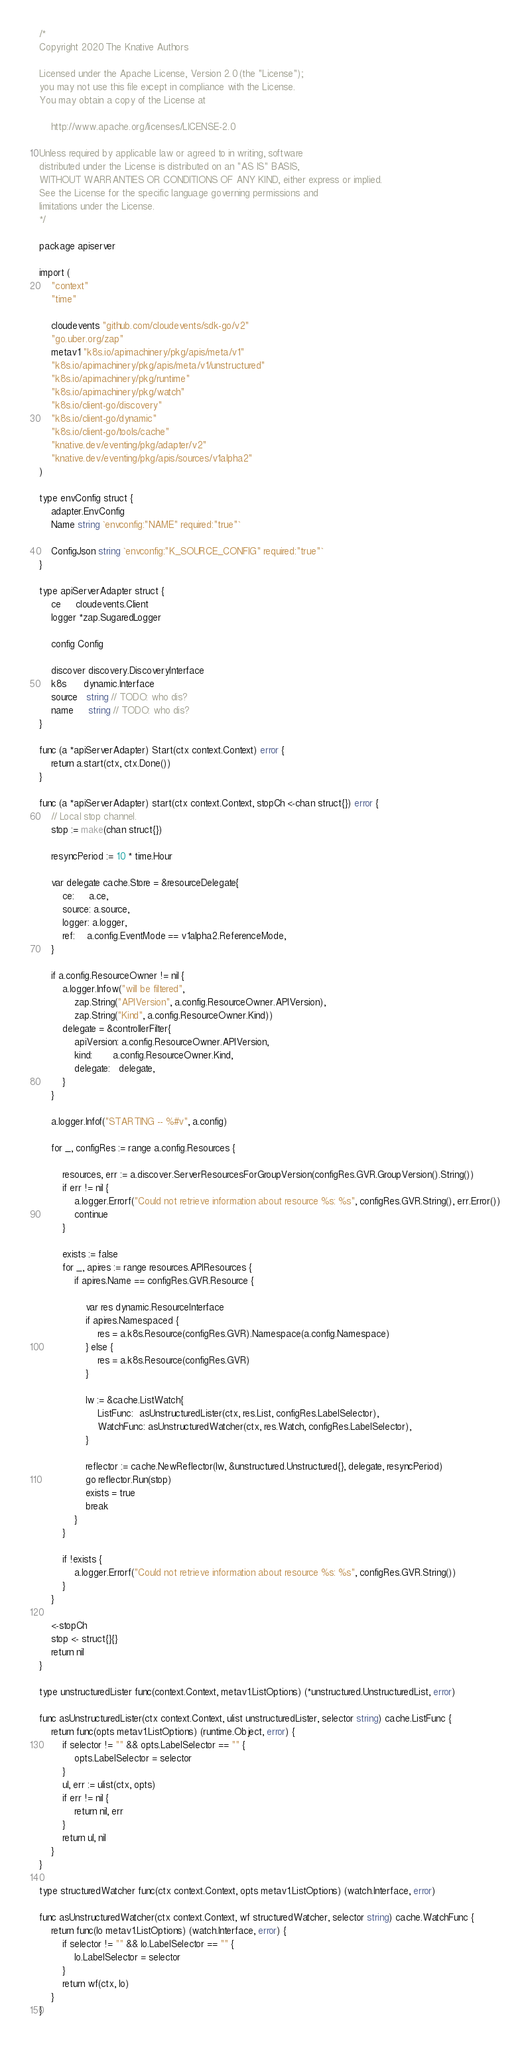Convert code to text. <code><loc_0><loc_0><loc_500><loc_500><_Go_>/*
Copyright 2020 The Knative Authors

Licensed under the Apache License, Version 2.0 (the "License");
you may not use this file except in compliance with the License.
You may obtain a copy of the License at

    http://www.apache.org/licenses/LICENSE-2.0

Unless required by applicable law or agreed to in writing, software
distributed under the License is distributed on an "AS IS" BASIS,
WITHOUT WARRANTIES OR CONDITIONS OF ANY KIND, either express or implied.
See the License for the specific language governing permissions and
limitations under the License.
*/

package apiserver

import (
	"context"
	"time"

	cloudevents "github.com/cloudevents/sdk-go/v2"
	"go.uber.org/zap"
	metav1 "k8s.io/apimachinery/pkg/apis/meta/v1"
	"k8s.io/apimachinery/pkg/apis/meta/v1/unstructured"
	"k8s.io/apimachinery/pkg/runtime"
	"k8s.io/apimachinery/pkg/watch"
	"k8s.io/client-go/discovery"
	"k8s.io/client-go/dynamic"
	"k8s.io/client-go/tools/cache"
	"knative.dev/eventing/pkg/adapter/v2"
	"knative.dev/eventing/pkg/apis/sources/v1alpha2"
)

type envConfig struct {
	adapter.EnvConfig
	Name string `envconfig:"NAME" required:"true"`

	ConfigJson string `envconfig:"K_SOURCE_CONFIG" required:"true"`
}

type apiServerAdapter struct {
	ce     cloudevents.Client
	logger *zap.SugaredLogger

	config Config

	discover discovery.DiscoveryInterface
	k8s      dynamic.Interface
	source   string // TODO: who dis?
	name     string // TODO: who dis?
}

func (a *apiServerAdapter) Start(ctx context.Context) error {
	return a.start(ctx, ctx.Done())
}

func (a *apiServerAdapter) start(ctx context.Context, stopCh <-chan struct{}) error {
	// Local stop channel.
	stop := make(chan struct{})

	resyncPeriod := 10 * time.Hour

	var delegate cache.Store = &resourceDelegate{
		ce:     a.ce,
		source: a.source,
		logger: a.logger,
		ref:    a.config.EventMode == v1alpha2.ReferenceMode,
	}

	if a.config.ResourceOwner != nil {
		a.logger.Infow("will be filtered",
			zap.String("APIVersion", a.config.ResourceOwner.APIVersion),
			zap.String("Kind", a.config.ResourceOwner.Kind))
		delegate = &controllerFilter{
			apiVersion: a.config.ResourceOwner.APIVersion,
			kind:       a.config.ResourceOwner.Kind,
			delegate:   delegate,
		}
	}

	a.logger.Infof("STARTING -- %#v", a.config)

	for _, configRes := range a.config.Resources {

		resources, err := a.discover.ServerResourcesForGroupVersion(configRes.GVR.GroupVersion().String())
		if err != nil {
			a.logger.Errorf("Could not retrieve information about resource %s: %s", configRes.GVR.String(), err.Error())
			continue
		}

		exists := false
		for _, apires := range resources.APIResources {
			if apires.Name == configRes.GVR.Resource {

				var res dynamic.ResourceInterface
				if apires.Namespaced {
					res = a.k8s.Resource(configRes.GVR).Namespace(a.config.Namespace)
				} else {
					res = a.k8s.Resource(configRes.GVR)
				}

				lw := &cache.ListWatch{
					ListFunc:  asUnstructuredLister(ctx, res.List, configRes.LabelSelector),
					WatchFunc: asUnstructuredWatcher(ctx, res.Watch, configRes.LabelSelector),
				}

				reflector := cache.NewReflector(lw, &unstructured.Unstructured{}, delegate, resyncPeriod)
				go reflector.Run(stop)
				exists = true
				break
			}
		}

		if !exists {
			a.logger.Errorf("Could not retrieve information about resource %s: %s", configRes.GVR.String())
		}
	}

	<-stopCh
	stop <- struct{}{}
	return nil
}

type unstructuredLister func(context.Context, metav1.ListOptions) (*unstructured.UnstructuredList, error)

func asUnstructuredLister(ctx context.Context, ulist unstructuredLister, selector string) cache.ListFunc {
	return func(opts metav1.ListOptions) (runtime.Object, error) {
		if selector != "" && opts.LabelSelector == "" {
			opts.LabelSelector = selector
		}
		ul, err := ulist(ctx, opts)
		if err != nil {
			return nil, err
		}
		return ul, nil
	}
}

type structuredWatcher func(ctx context.Context, opts metav1.ListOptions) (watch.Interface, error)

func asUnstructuredWatcher(ctx context.Context, wf structuredWatcher, selector string) cache.WatchFunc {
	return func(lo metav1.ListOptions) (watch.Interface, error) {
		if selector != "" && lo.LabelSelector == "" {
			lo.LabelSelector = selector
		}
		return wf(ctx, lo)
	}
}
</code> 